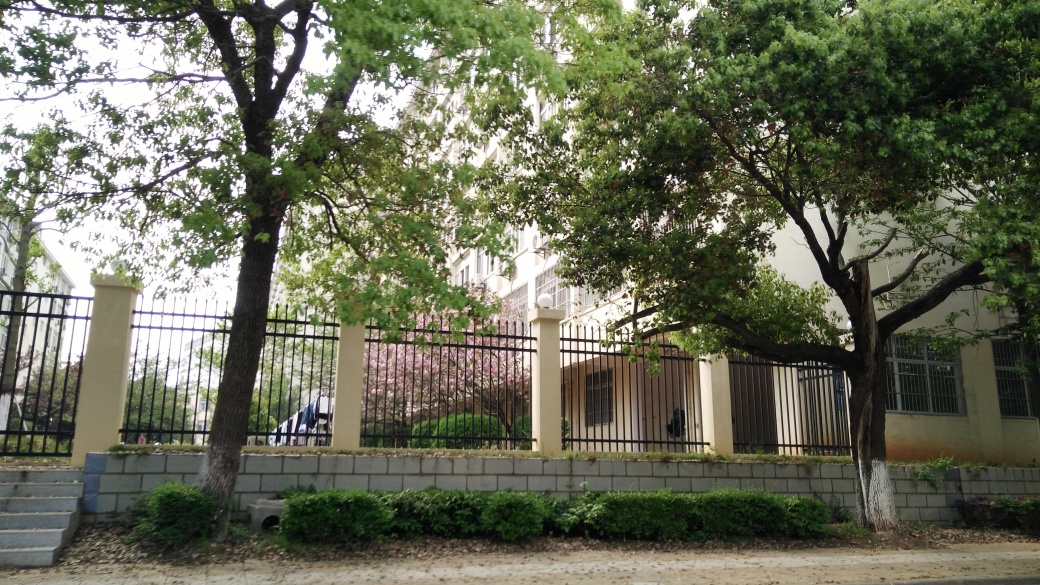Can you describe the atmosphere or mood that this image conveys? The image exudes a peaceful and tranquil ambience. The lush greenery of the trees provides a sense of serenity, while the softly lit environment and the absence of people contribute to a quiet, undisturbed mood. It feels like a moment of solitude in an urban setting. 